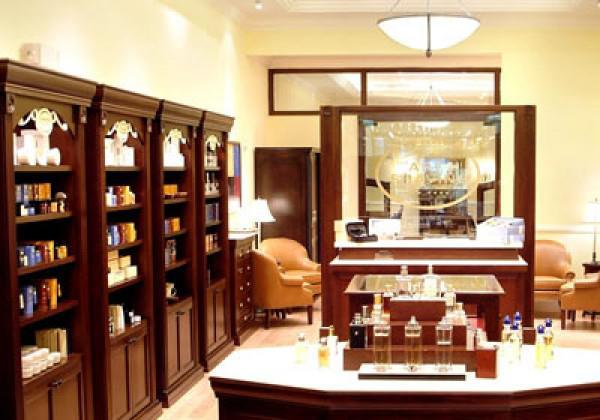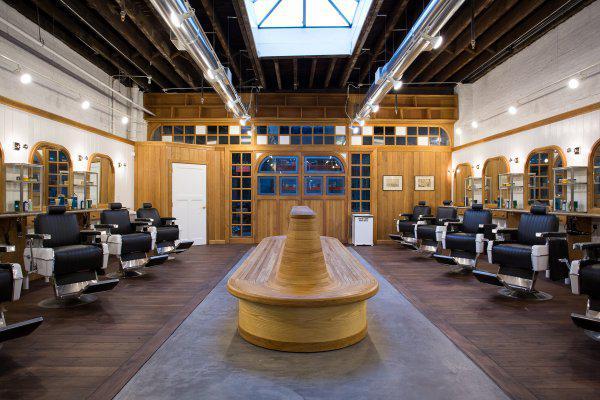The first image is the image on the left, the second image is the image on the right. For the images shown, is this caption "One of the images contains a bench for seating in the middle of the room" true? Answer yes or no. Yes. The first image is the image on the left, the second image is the image on the right. For the images shown, is this caption "A long oblong counter with a peaked top is in the center of the salon, flanked by barber chairs, in one image." true? Answer yes or no. Yes. 